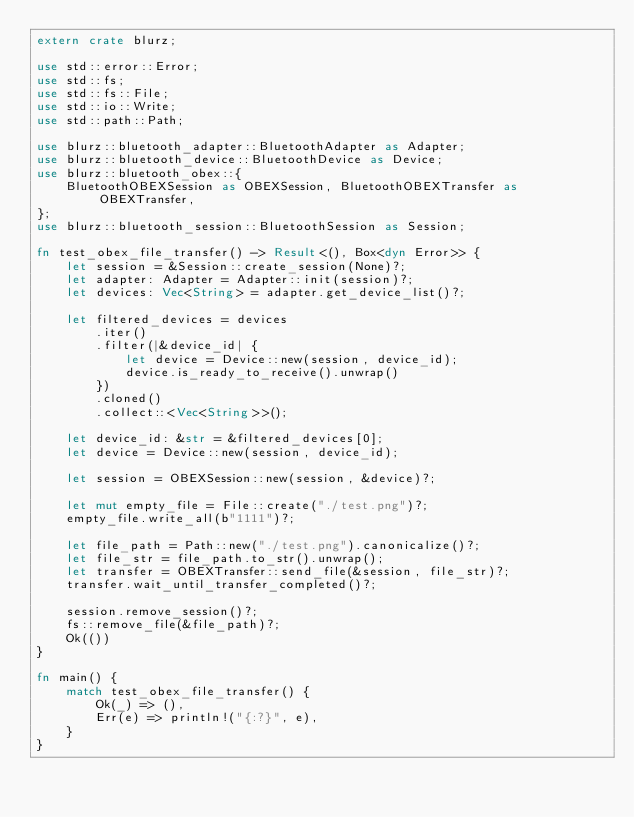<code> <loc_0><loc_0><loc_500><loc_500><_Rust_>extern crate blurz;

use std::error::Error;
use std::fs;
use std::fs::File;
use std::io::Write;
use std::path::Path;

use blurz::bluetooth_adapter::BluetoothAdapter as Adapter;
use blurz::bluetooth_device::BluetoothDevice as Device;
use blurz::bluetooth_obex::{
    BluetoothOBEXSession as OBEXSession, BluetoothOBEXTransfer as OBEXTransfer,
};
use blurz::bluetooth_session::BluetoothSession as Session;

fn test_obex_file_transfer() -> Result<(), Box<dyn Error>> {
    let session = &Session::create_session(None)?;
    let adapter: Adapter = Adapter::init(session)?;
    let devices: Vec<String> = adapter.get_device_list()?;

    let filtered_devices = devices
        .iter()
        .filter(|&device_id| {
            let device = Device::new(session, device_id);
            device.is_ready_to_receive().unwrap()
        })
        .cloned()
        .collect::<Vec<String>>();

    let device_id: &str = &filtered_devices[0];
    let device = Device::new(session, device_id);

    let session = OBEXSession::new(session, &device)?;

    let mut empty_file = File::create("./test.png")?;
    empty_file.write_all(b"1111")?;

    let file_path = Path::new("./test.png").canonicalize()?;
    let file_str = file_path.to_str().unwrap();
    let transfer = OBEXTransfer::send_file(&session, file_str)?;
    transfer.wait_until_transfer_completed()?;

    session.remove_session()?;
    fs::remove_file(&file_path)?;
    Ok(())
}

fn main() {
    match test_obex_file_transfer() {
        Ok(_) => (),
        Err(e) => println!("{:?}", e),
    }
}
</code> 